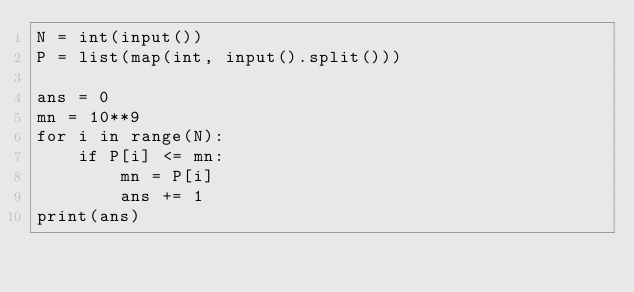Convert code to text. <code><loc_0><loc_0><loc_500><loc_500><_Python_>N = int(input())
P = list(map(int, input().split()))

ans = 0
mn = 10**9
for i in range(N):
    if P[i] <= mn:
        mn = P[i]
        ans += 1
print(ans)
</code> 